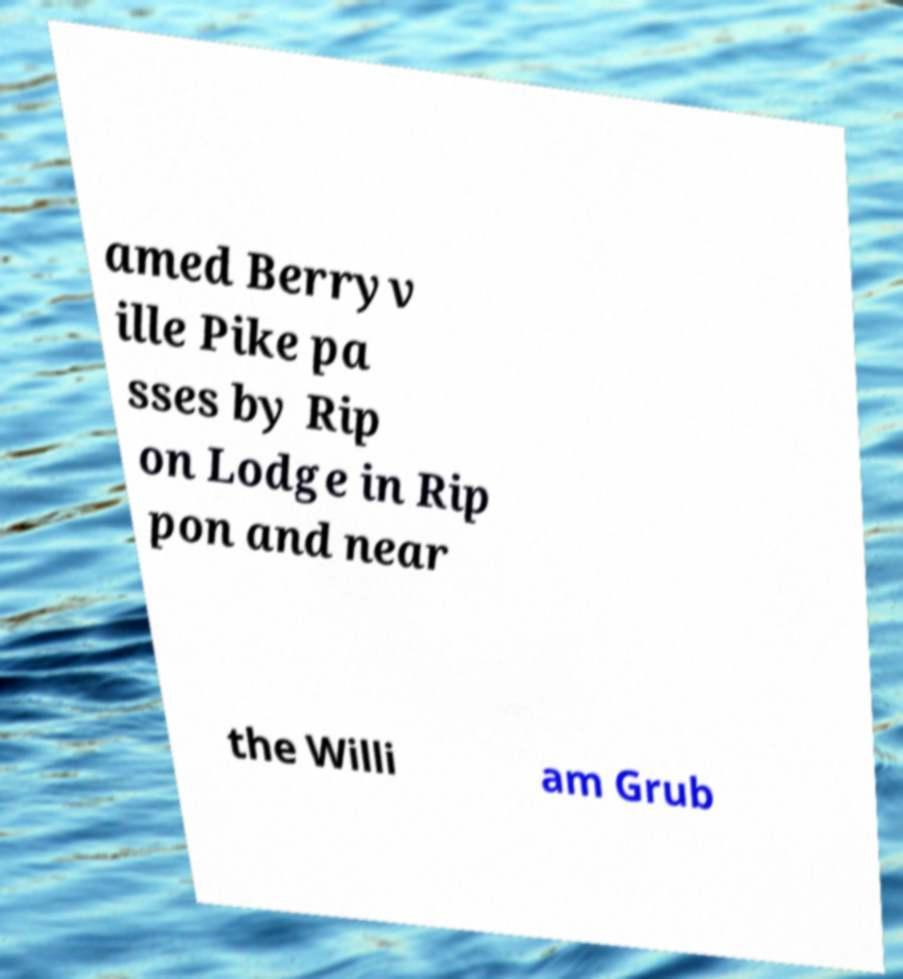Can you read and provide the text displayed in the image?This photo seems to have some interesting text. Can you extract and type it out for me? amed Berryv ille Pike pa sses by Rip on Lodge in Rip pon and near the Willi am Grub 